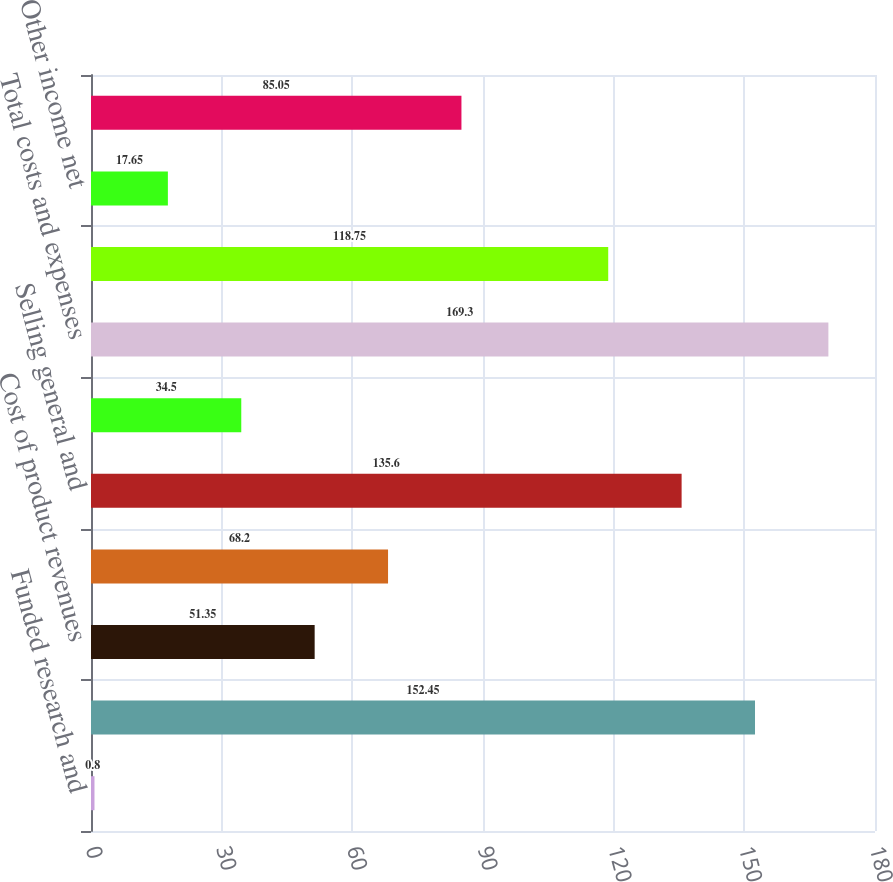Convert chart to OTSL. <chart><loc_0><loc_0><loc_500><loc_500><bar_chart><fcel>Funded research and<fcel>Total revenues<fcel>Cost of product revenues<fcel>Research and development<fcel>Selling general and<fcel>Amortization of intangibles<fcel>Total costs and expenses<fcel>Loss from operations<fcel>Other income net<fcel>Loss before income taxes<nl><fcel>0.8<fcel>152.45<fcel>51.35<fcel>68.2<fcel>135.6<fcel>34.5<fcel>169.3<fcel>118.75<fcel>17.65<fcel>85.05<nl></chart> 